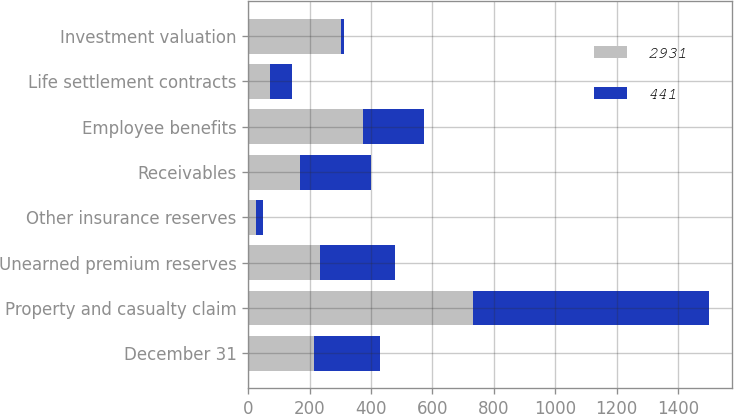<chart> <loc_0><loc_0><loc_500><loc_500><stacked_bar_chart><ecel><fcel>December 31<fcel>Property and casualty claim<fcel>Unearned premium reserves<fcel>Other insurance reserves<fcel>Receivables<fcel>Employee benefits<fcel>Life settlement contracts<fcel>Investment valuation<nl><fcel>2931<fcel>215<fcel>731<fcel>234<fcel>24<fcel>169<fcel>373<fcel>70<fcel>303<nl><fcel>441<fcel>215<fcel>771<fcel>243<fcel>24<fcel>231<fcel>199<fcel>73<fcel>8<nl></chart> 